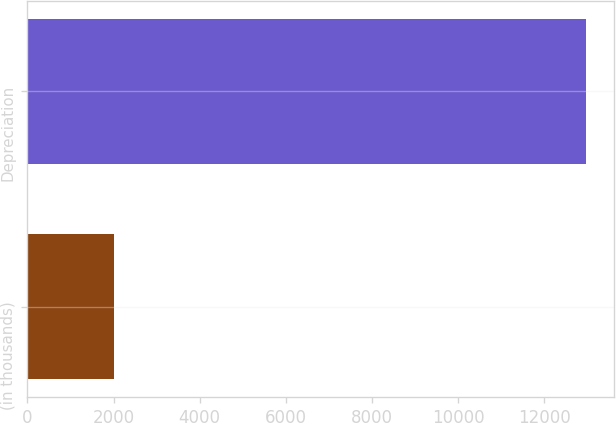Convert chart to OTSL. <chart><loc_0><loc_0><loc_500><loc_500><bar_chart><fcel>(in thousands)<fcel>Depreciation<nl><fcel>2006<fcel>12976<nl></chart> 